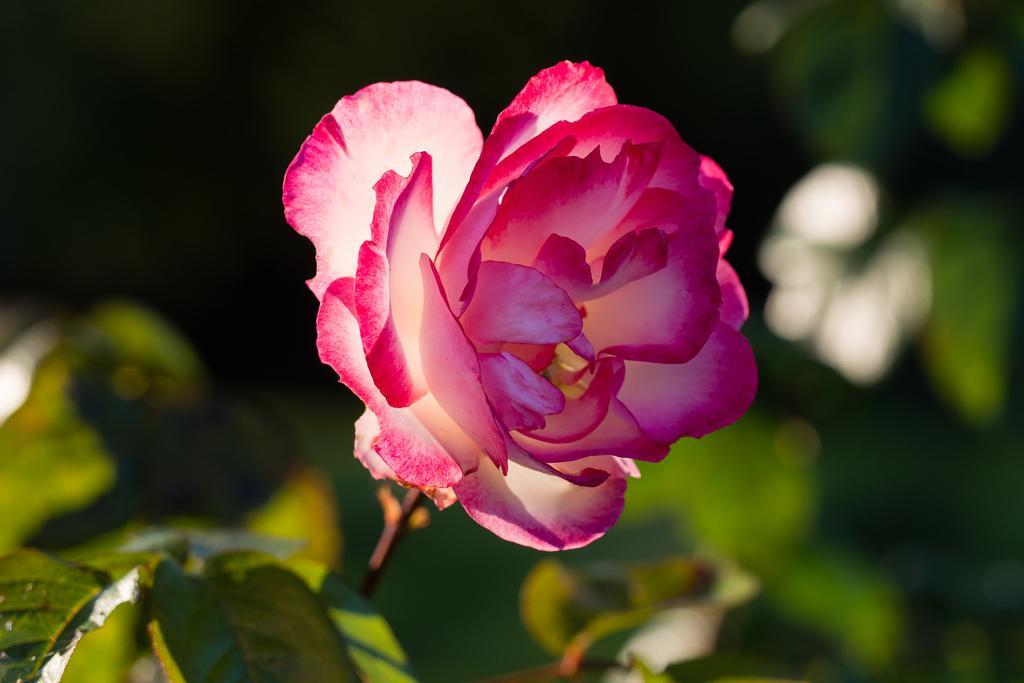Describe this image in one or two sentences. In this picture we can see a flower and some leaves in the front, there is a blurry background. 